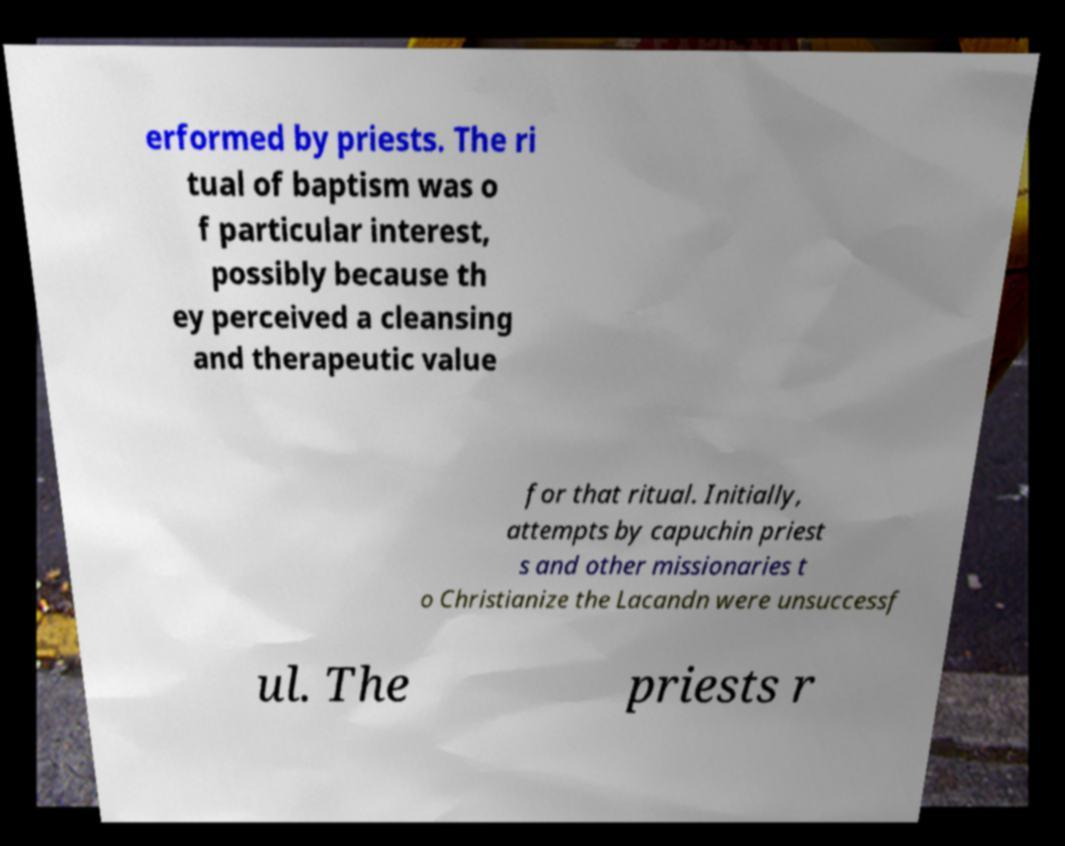Could you extract and type out the text from this image? erformed by priests. The ri tual of baptism was o f particular interest, possibly because th ey perceived a cleansing and therapeutic value for that ritual. Initially, attempts by capuchin priest s and other missionaries t o Christianize the Lacandn were unsuccessf ul. The priests r 